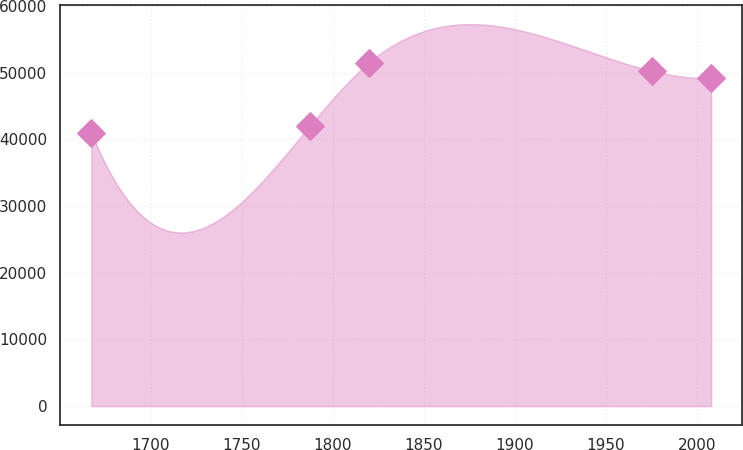<chart> <loc_0><loc_0><loc_500><loc_500><line_chart><ecel><fcel>Unnamed: 1<nl><fcel>1667.41<fcel>40944.8<nl><fcel>1787.49<fcel>41996.9<nl><fcel>1819.88<fcel>51466.2<nl><fcel>1975.47<fcel>50223<nl><fcel>2007.86<fcel>49170.9<nl></chart> 